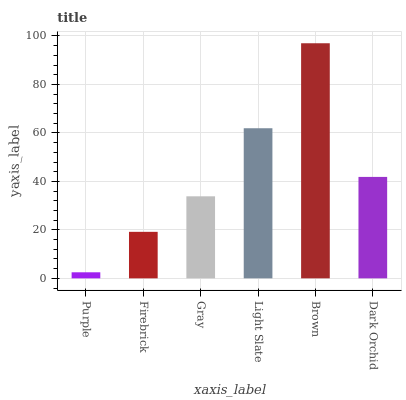Is Purple the minimum?
Answer yes or no. Yes. Is Brown the maximum?
Answer yes or no. Yes. Is Firebrick the minimum?
Answer yes or no. No. Is Firebrick the maximum?
Answer yes or no. No. Is Firebrick greater than Purple?
Answer yes or no. Yes. Is Purple less than Firebrick?
Answer yes or no. Yes. Is Purple greater than Firebrick?
Answer yes or no. No. Is Firebrick less than Purple?
Answer yes or no. No. Is Dark Orchid the high median?
Answer yes or no. Yes. Is Gray the low median?
Answer yes or no. Yes. Is Light Slate the high median?
Answer yes or no. No. Is Firebrick the low median?
Answer yes or no. No. 